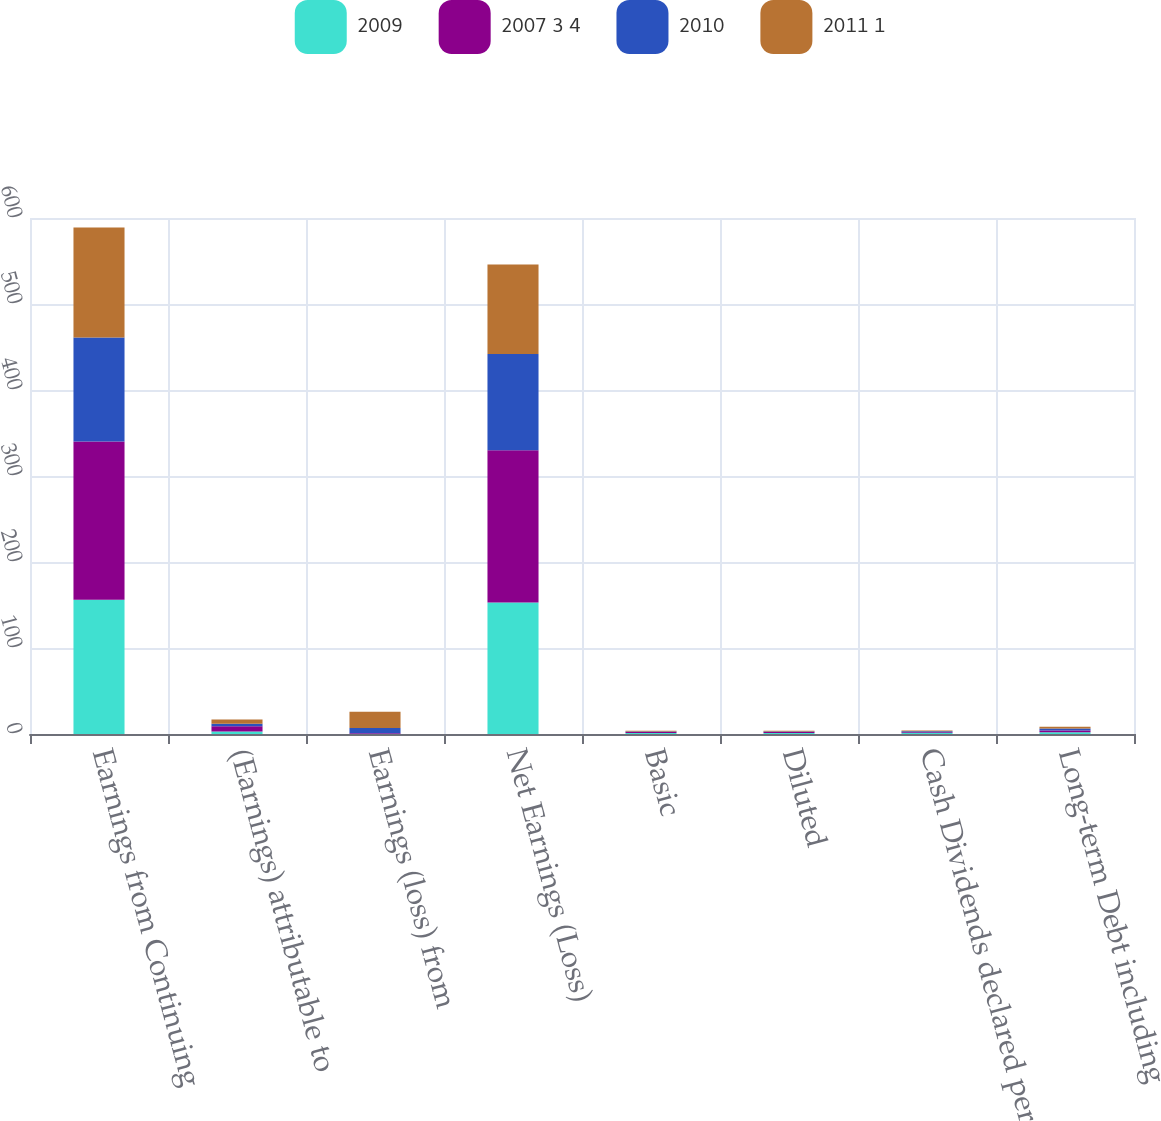Convert chart to OTSL. <chart><loc_0><loc_0><loc_500><loc_500><stacked_bar_chart><ecel><fcel>Earnings from Continuing<fcel>(Earnings) attributable to<fcel>Earnings (loss) from<fcel>Net Earnings (Loss)<fcel>Basic<fcel>Diluted<fcel>Cash Dividends declared per<fcel>Long-term Debt including<nl><fcel>2009<fcel>156<fcel>3<fcel>0<fcel>153<fcel>1.05<fcel>1.04<fcel>1.1<fcel>2.085<nl><fcel>2007 3 4<fcel>184<fcel>6<fcel>1<fcel>177<fcel>1.17<fcel>1.16<fcel>1.06<fcel>2.085<nl><fcel>2010<fcel>121<fcel>3<fcel>6<fcel>112<fcel>0.74<fcel>0.74<fcel>1.02<fcel>2.085<nl><fcel>2011 1<fcel>128<fcel>5<fcel>19<fcel>104<fcel>0.73<fcel>0.73<fcel>1<fcel>2.085<nl></chart> 